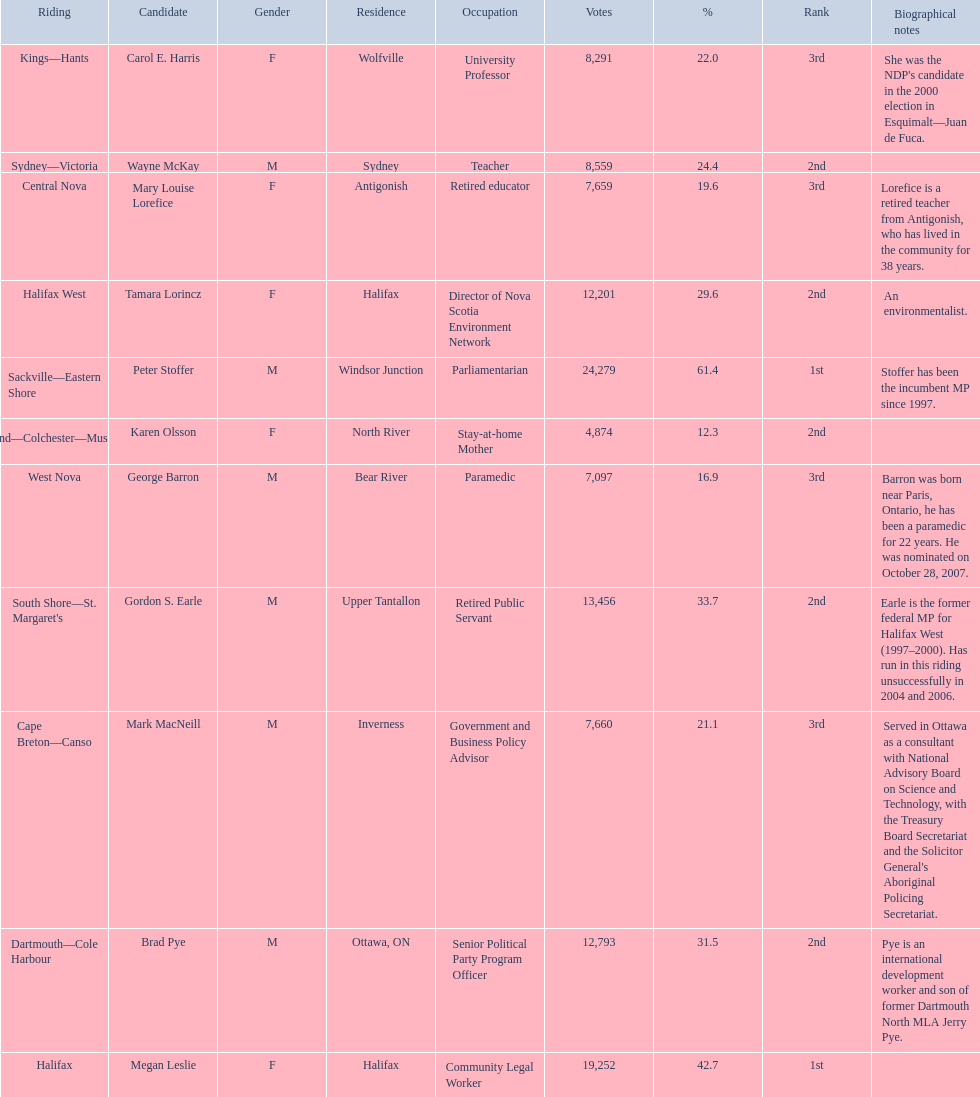How many votes did macneill receive? 7,660. How many votes did olsoon receive? 4,874. Between macneil and olsson, who received more votes? Mark MacNeill. 